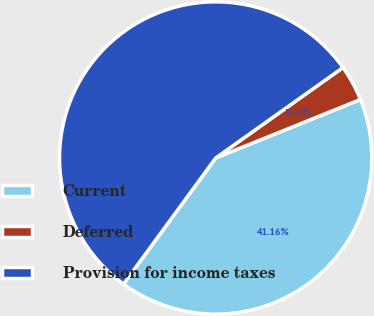Convert chart. <chart><loc_0><loc_0><loc_500><loc_500><pie_chart><fcel>Current<fcel>Deferred<fcel>Provision for income taxes<nl><fcel>41.16%<fcel>3.72%<fcel>55.12%<nl></chart> 